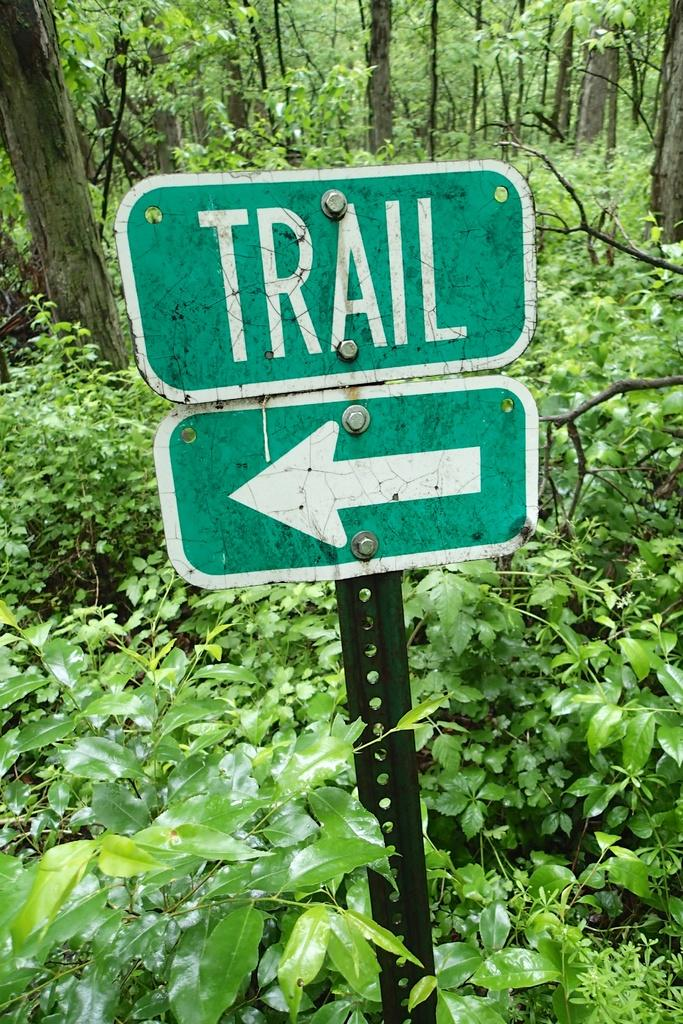What is in the middle of the image? There are two boards fixed to a pole in the middle of the image. What can be seen in the background of the image? There are trees and plants on the ground in the background of the image. What type of shock can be seen on the boards in the image? There is no shock present on the boards in the image. Is there a crook standing near the boards in the image? There is no crook present in the image. 